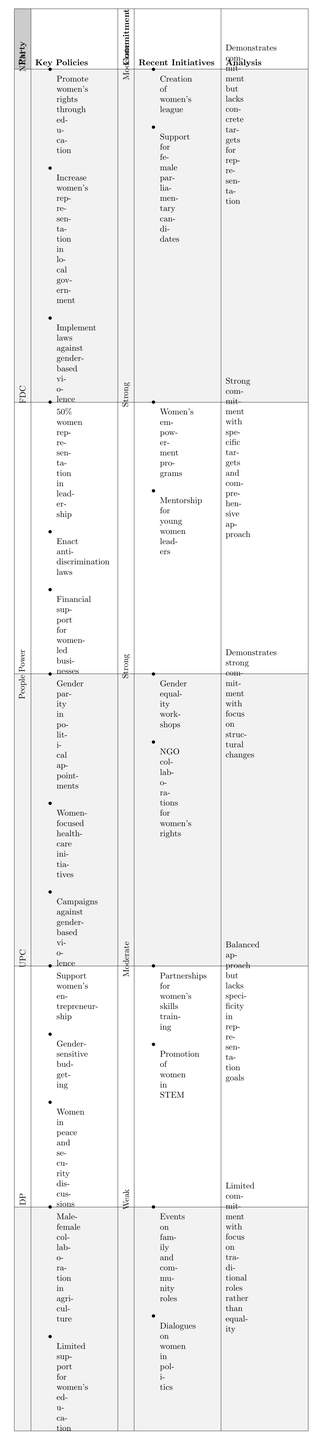What is the gender equality commitment level of the National Resistance Movement (NRM)? The table explicitly states that the gender equality commitment level for NRM is categorized as "Moderate."
Answer: Moderate Which party has a strong commitment to gender equality and focuses on 50% representation in leadership? From the table, the Forum for Democratic Change (FDC) has a strong commitment to gender equality and emphasizes 50% representation in leadership positions.
Answer: Forum for Democratic Change (FDC) What recent initiative did the People Power Movement implement to promote gender equality? The People Power Movement has organized gender equality workshops across districts as a recent initiative to promote gender equality.
Answer: Gender equality workshops Is the Democratic Party (DP) committed to initiatives that support women's education? The table indicates that DP offers limited support for women's education, therefore, it is not significantly committed to this initiative.
Answer: No Which party shows a balance between moderate commitment and specific key policies aimed at women's advancement? Uganda People's Congress (UPC) demonstrates a balanced approach with moderate commitment while also having key policies focused on women's entrepreneurship and participation in discussions.
Answer: Uganda People's Congress (UPC) How many political parties have a strong commitment to gender equality based on the table? The table lists two parties with a strong commitment to gender equality: Forum for Democratic Change (FDC) and People Power Movement. Therefore, the count is two.
Answer: Two What is the main challenge highlighted about the gender equality initiatives of the National Resistance Movement (NRM)? The analysis for NRM points out that while there is a commitment, it lacks concrete targets for representation, which is a significant challenge.
Answer: Lack of concrete targets Out of the political parties listed, which two have moderate gender equality commitments? The table identifies National Resistance Movement (NRM) and Uganda People's Congress (UPC) as parties with moderate gender equality commitments.
Answer: NRM and UPC What type of recent initiatives does the Democratic Party (DP) focus on? The recent initiatives of DP focus on traditional roles, with events oriented around family and community roles rather than direct support for gender equality initiatives.
Answer: Traditional roles Considering all parties, what is the predominant form of support offered by the Forum for Democratic Change (FDC)? The FDC primarily offers strong support through specific policies aimed at achieving significant representation and legal protections for women, thus shaping a robust approach to gender equality.
Answer: Legal protections and representation 